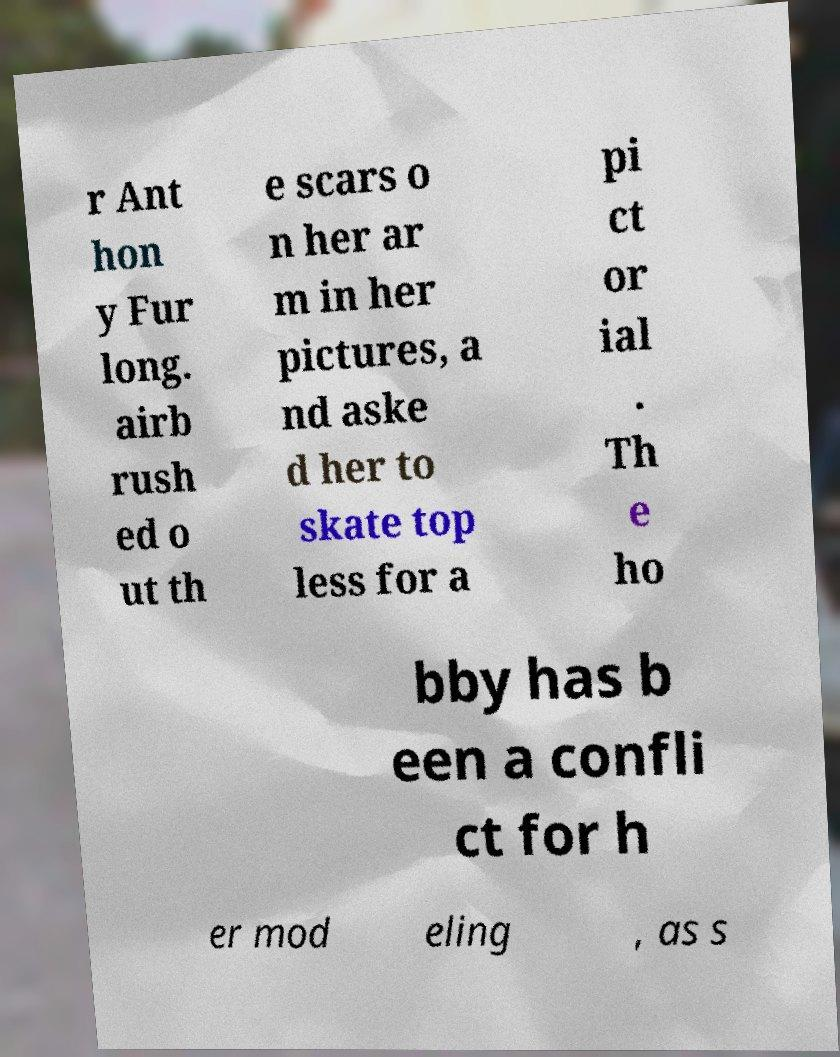I need the written content from this picture converted into text. Can you do that? r Ant hon y Fur long. airb rush ed o ut th e scars o n her ar m in her pictures, a nd aske d her to skate top less for a pi ct or ial . Th e ho bby has b een a confli ct for h er mod eling , as s 